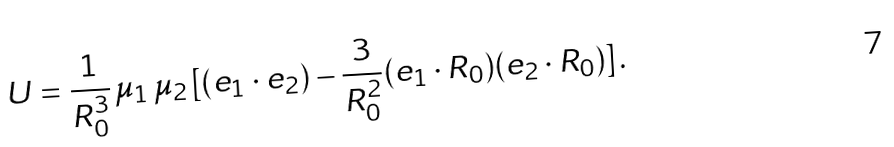Convert formula to latex. <formula><loc_0><loc_0><loc_500><loc_500>U = \frac { 1 } { R ^ { 3 } _ { 0 } } \, \mu _ { 1 } \, \mu _ { 2 } \, [ ( { e } _ { 1 } \cdot { e } _ { 2 } ) - \frac { 3 } { R ^ { 2 } _ { 0 } } ( { e } _ { 1 } \cdot { R } _ { 0 } ) ( { e } _ { 2 } \cdot { R } _ { 0 } ) ] \, .</formula> 